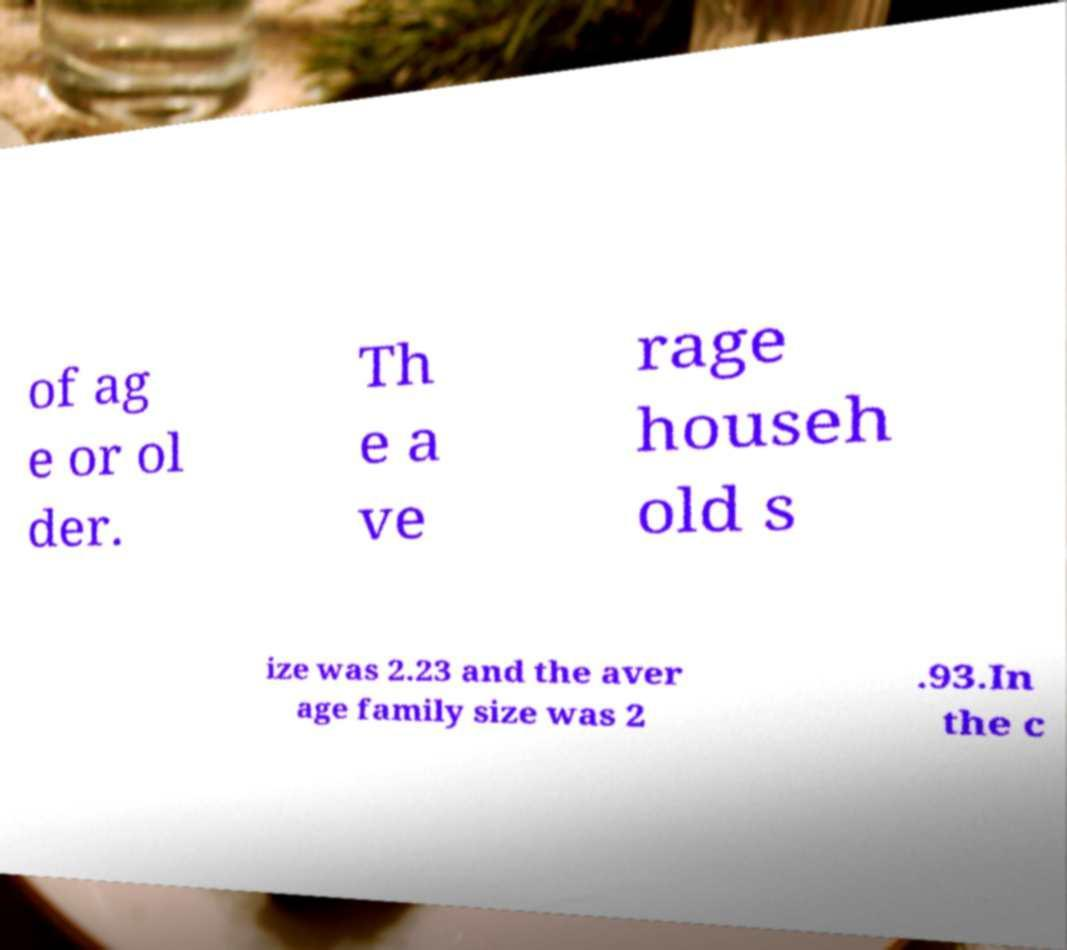Could you assist in decoding the text presented in this image and type it out clearly? of ag e or ol der. Th e a ve rage househ old s ize was 2.23 and the aver age family size was 2 .93.In the c 